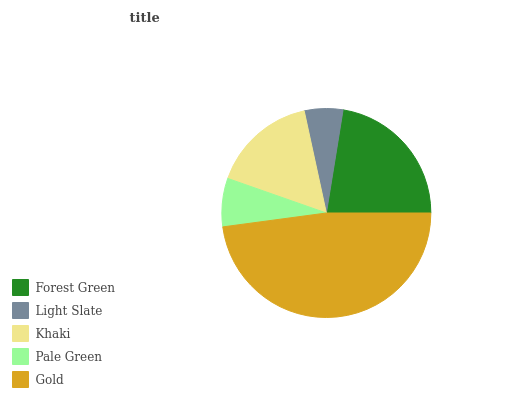Is Light Slate the minimum?
Answer yes or no. Yes. Is Gold the maximum?
Answer yes or no. Yes. Is Khaki the minimum?
Answer yes or no. No. Is Khaki the maximum?
Answer yes or no. No. Is Khaki greater than Light Slate?
Answer yes or no. Yes. Is Light Slate less than Khaki?
Answer yes or no. Yes. Is Light Slate greater than Khaki?
Answer yes or no. No. Is Khaki less than Light Slate?
Answer yes or no. No. Is Khaki the high median?
Answer yes or no. Yes. Is Khaki the low median?
Answer yes or no. Yes. Is Pale Green the high median?
Answer yes or no. No. Is Pale Green the low median?
Answer yes or no. No. 